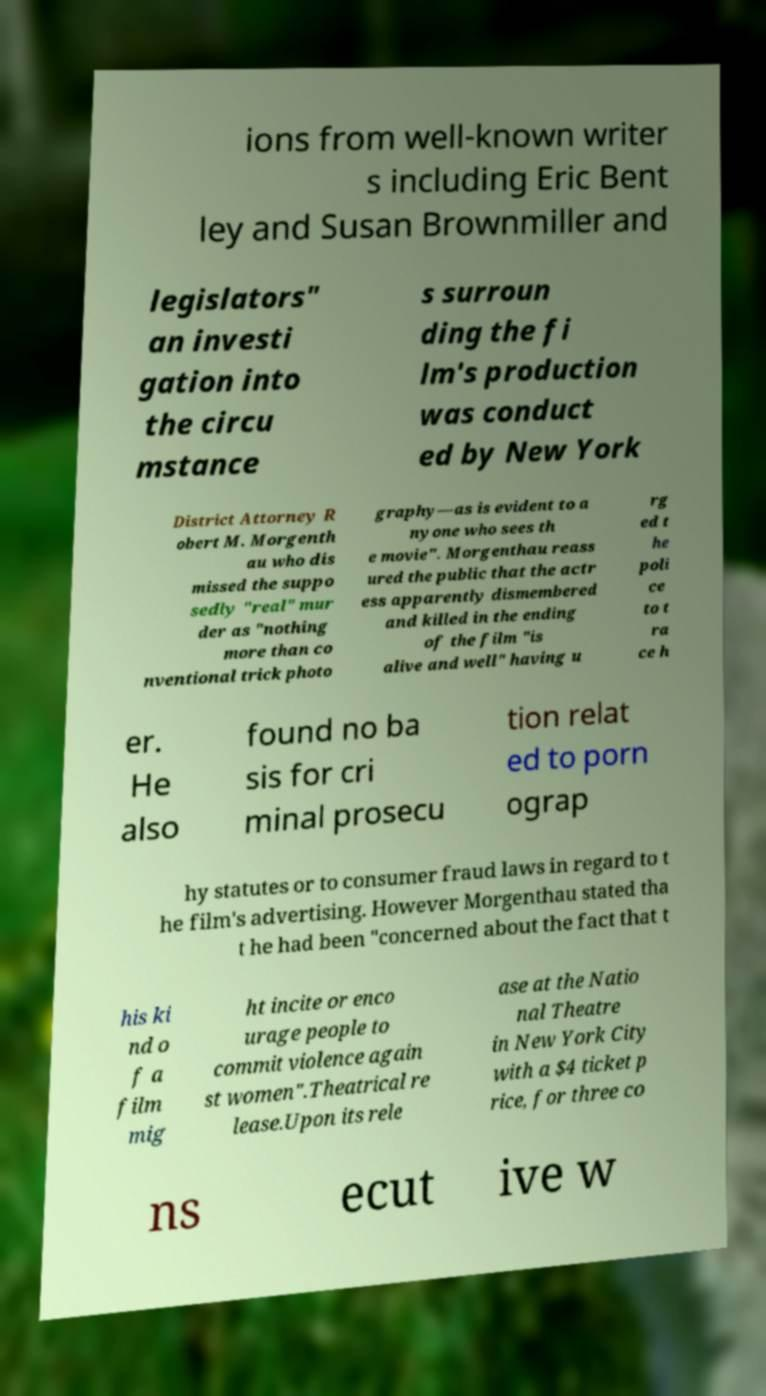Could you assist in decoding the text presented in this image and type it out clearly? ions from well-known writer s including Eric Bent ley and Susan Brownmiller and legislators" an investi gation into the circu mstance s surroun ding the fi lm's production was conduct ed by New York District Attorney R obert M. Morgenth au who dis missed the suppo sedly "real" mur der as "nothing more than co nventional trick photo graphy—as is evident to a nyone who sees th e movie". Morgenthau reass ured the public that the actr ess apparently dismembered and killed in the ending of the film "is alive and well" having u rg ed t he poli ce to t ra ce h er. He also found no ba sis for cri minal prosecu tion relat ed to porn ograp hy statutes or to consumer fraud laws in regard to t he film's advertising. However Morgenthau stated tha t he had been "concerned about the fact that t his ki nd o f a film mig ht incite or enco urage people to commit violence again st women".Theatrical re lease.Upon its rele ase at the Natio nal Theatre in New York City with a $4 ticket p rice, for three co ns ecut ive w 